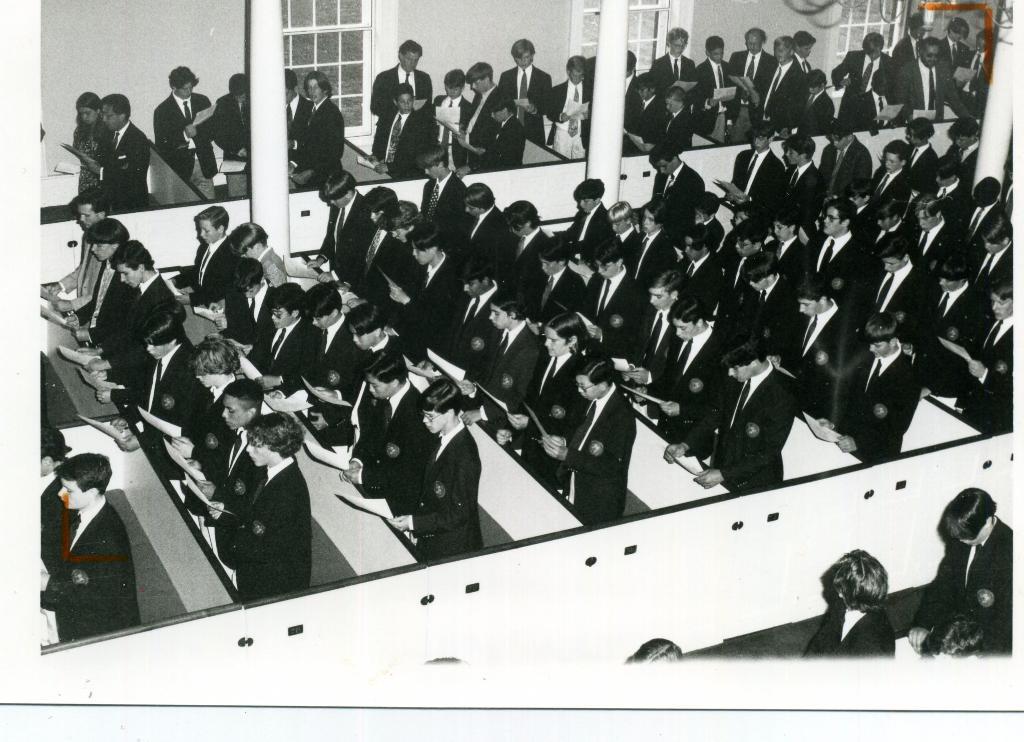Please provide a concise description of this image. This looks like a black and white image. I can see groups of people standing and holding papers in their hands. I can see the pillars. At the top of the image, these look like the windows. 